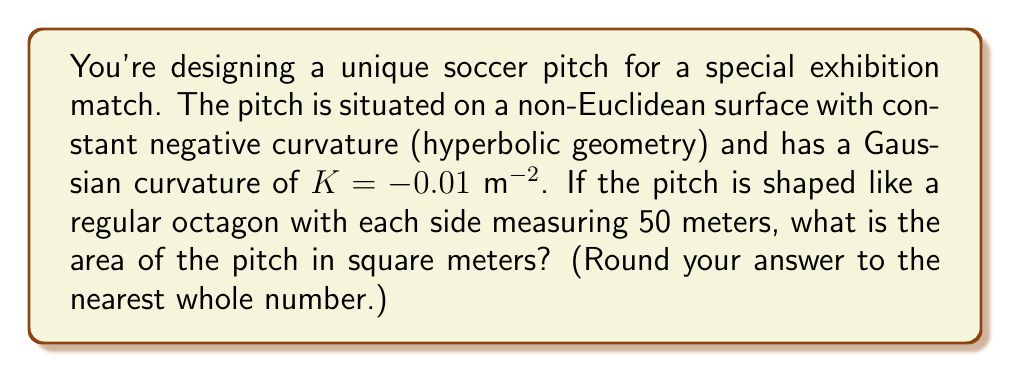Could you help me with this problem? To solve this problem, we'll use the Gauss-Bonnet theorem for hyperbolic geometry. Here's the step-by-step solution:

1) In hyperbolic geometry, the area of a regular n-gon is given by:

   $$ A = \frac{(n-2)\pi - \sum_{i=1}^n \theta_i}{-K} $$

   where $n$ is the number of sides, $\theta_i$ are the interior angles, and $K$ is the Gaussian curvature.

2) For a regular octagon, $n = 8$.

3) In Euclidean geometry, the interior angle of a regular octagon is $(n-2)\frac{\pi}{n} = \frac{3\pi}{4}$.

4) However, in hyperbolic geometry, the sum of the angles of a polygon is less than $(n-2)\pi$. The defect is equal to the area of the polygon multiplied by $-K$.

5) Let's denote the interior angle of our hyperbolic octagon as $\theta$. We can set up the equation:

   $$ 8\theta = (8-2)\pi + KA = 6\pi + KA $$

6) Substituting this into the area formula:

   $$ A = \frac{6\pi - 8\theta}{-K} = \frac{6\pi - (6\pi + KA)}{-K} = \frac{-KA}{-K} = A $$

7) This confirms that our formula is consistent. Now we need to find $\theta$.

8) In hyperbolic geometry, for a regular octagon with side length $s$, we have:

   $$ \cosh(\sqrt{-K}s) = \frac{\cos(\pi/8)}{\sin(\theta/2)} $$

9) Substituting our values:

   $$ \cosh(0.1\sqrt{50}) \approx 1.2533 = \frac{\cos(\pi/8)}{\sin(\theta/2)} $$

10) Solving for $\theta$:

    $$ \theta = 2\arcsin(\frac{\cos(\pi/8)}{1.2533}) \approx 1.3498 $$

11) Now we can calculate the area:

    $$ A = \frac{6\pi - 8(1.3498)}{0.01} \approx 8145.7 \text{ m}^2 $$

12) Rounding to the nearest whole number, we get 8146 m².
Answer: 8146 m² 